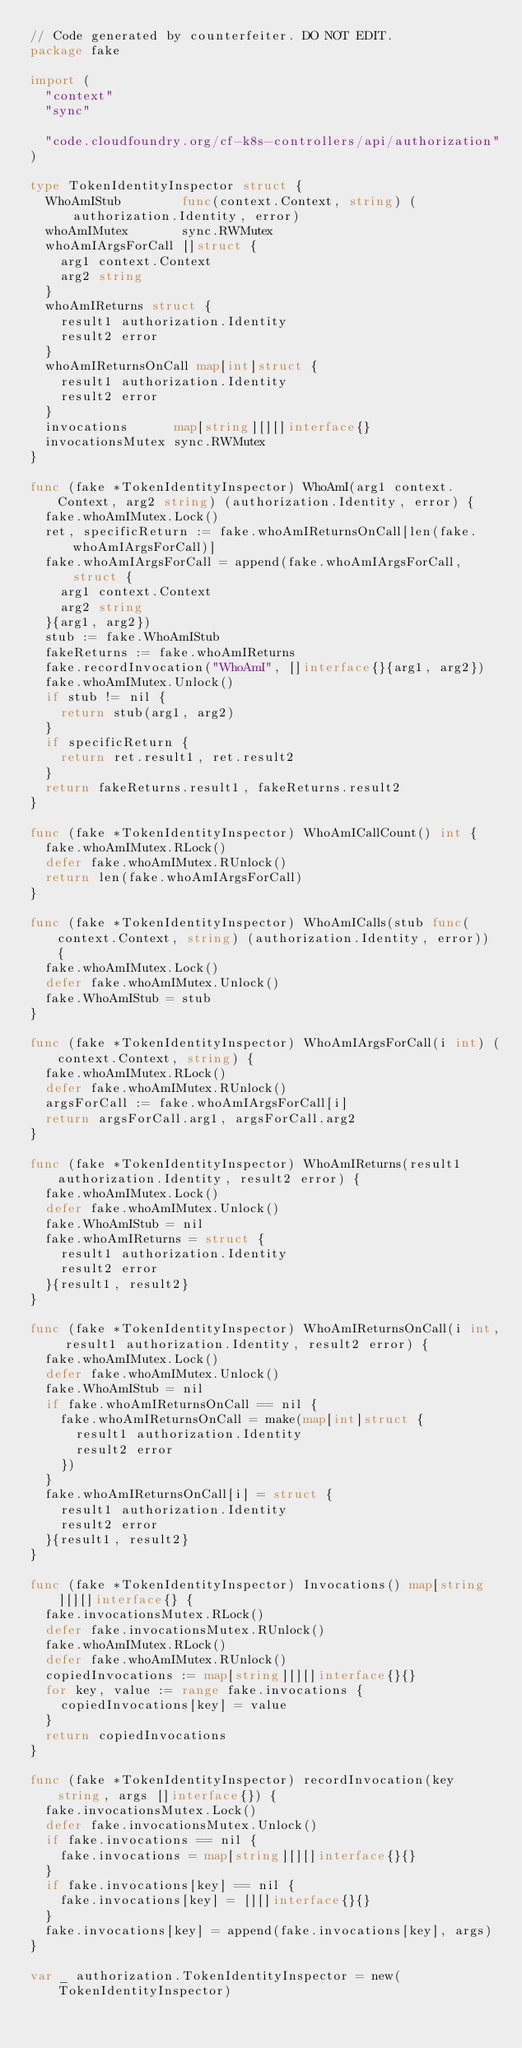Convert code to text. <code><loc_0><loc_0><loc_500><loc_500><_Go_>// Code generated by counterfeiter. DO NOT EDIT.
package fake

import (
	"context"
	"sync"

	"code.cloudfoundry.org/cf-k8s-controllers/api/authorization"
)

type TokenIdentityInspector struct {
	WhoAmIStub        func(context.Context, string) (authorization.Identity, error)
	whoAmIMutex       sync.RWMutex
	whoAmIArgsForCall []struct {
		arg1 context.Context
		arg2 string
	}
	whoAmIReturns struct {
		result1 authorization.Identity
		result2 error
	}
	whoAmIReturnsOnCall map[int]struct {
		result1 authorization.Identity
		result2 error
	}
	invocations      map[string][][]interface{}
	invocationsMutex sync.RWMutex
}

func (fake *TokenIdentityInspector) WhoAmI(arg1 context.Context, arg2 string) (authorization.Identity, error) {
	fake.whoAmIMutex.Lock()
	ret, specificReturn := fake.whoAmIReturnsOnCall[len(fake.whoAmIArgsForCall)]
	fake.whoAmIArgsForCall = append(fake.whoAmIArgsForCall, struct {
		arg1 context.Context
		arg2 string
	}{arg1, arg2})
	stub := fake.WhoAmIStub
	fakeReturns := fake.whoAmIReturns
	fake.recordInvocation("WhoAmI", []interface{}{arg1, arg2})
	fake.whoAmIMutex.Unlock()
	if stub != nil {
		return stub(arg1, arg2)
	}
	if specificReturn {
		return ret.result1, ret.result2
	}
	return fakeReturns.result1, fakeReturns.result2
}

func (fake *TokenIdentityInspector) WhoAmICallCount() int {
	fake.whoAmIMutex.RLock()
	defer fake.whoAmIMutex.RUnlock()
	return len(fake.whoAmIArgsForCall)
}

func (fake *TokenIdentityInspector) WhoAmICalls(stub func(context.Context, string) (authorization.Identity, error)) {
	fake.whoAmIMutex.Lock()
	defer fake.whoAmIMutex.Unlock()
	fake.WhoAmIStub = stub
}

func (fake *TokenIdentityInspector) WhoAmIArgsForCall(i int) (context.Context, string) {
	fake.whoAmIMutex.RLock()
	defer fake.whoAmIMutex.RUnlock()
	argsForCall := fake.whoAmIArgsForCall[i]
	return argsForCall.arg1, argsForCall.arg2
}

func (fake *TokenIdentityInspector) WhoAmIReturns(result1 authorization.Identity, result2 error) {
	fake.whoAmIMutex.Lock()
	defer fake.whoAmIMutex.Unlock()
	fake.WhoAmIStub = nil
	fake.whoAmIReturns = struct {
		result1 authorization.Identity
		result2 error
	}{result1, result2}
}

func (fake *TokenIdentityInspector) WhoAmIReturnsOnCall(i int, result1 authorization.Identity, result2 error) {
	fake.whoAmIMutex.Lock()
	defer fake.whoAmIMutex.Unlock()
	fake.WhoAmIStub = nil
	if fake.whoAmIReturnsOnCall == nil {
		fake.whoAmIReturnsOnCall = make(map[int]struct {
			result1 authorization.Identity
			result2 error
		})
	}
	fake.whoAmIReturnsOnCall[i] = struct {
		result1 authorization.Identity
		result2 error
	}{result1, result2}
}

func (fake *TokenIdentityInspector) Invocations() map[string][][]interface{} {
	fake.invocationsMutex.RLock()
	defer fake.invocationsMutex.RUnlock()
	fake.whoAmIMutex.RLock()
	defer fake.whoAmIMutex.RUnlock()
	copiedInvocations := map[string][][]interface{}{}
	for key, value := range fake.invocations {
		copiedInvocations[key] = value
	}
	return copiedInvocations
}

func (fake *TokenIdentityInspector) recordInvocation(key string, args []interface{}) {
	fake.invocationsMutex.Lock()
	defer fake.invocationsMutex.Unlock()
	if fake.invocations == nil {
		fake.invocations = map[string][][]interface{}{}
	}
	if fake.invocations[key] == nil {
		fake.invocations[key] = [][]interface{}{}
	}
	fake.invocations[key] = append(fake.invocations[key], args)
}

var _ authorization.TokenIdentityInspector = new(TokenIdentityInspector)
</code> 